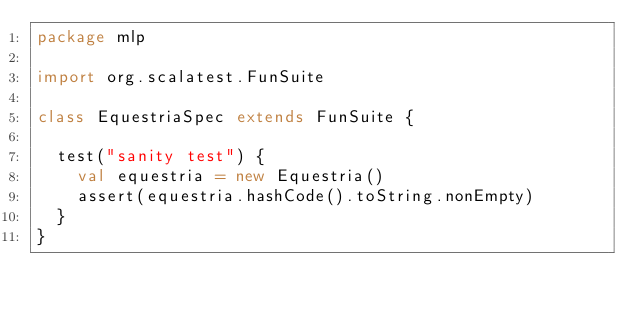<code> <loc_0><loc_0><loc_500><loc_500><_Scala_>package mlp

import org.scalatest.FunSuite

class EquestriaSpec extends FunSuite {

  test("sanity test") {
    val equestria = new Equestria()
    assert(equestria.hashCode().toString.nonEmpty)
  }
}
</code> 